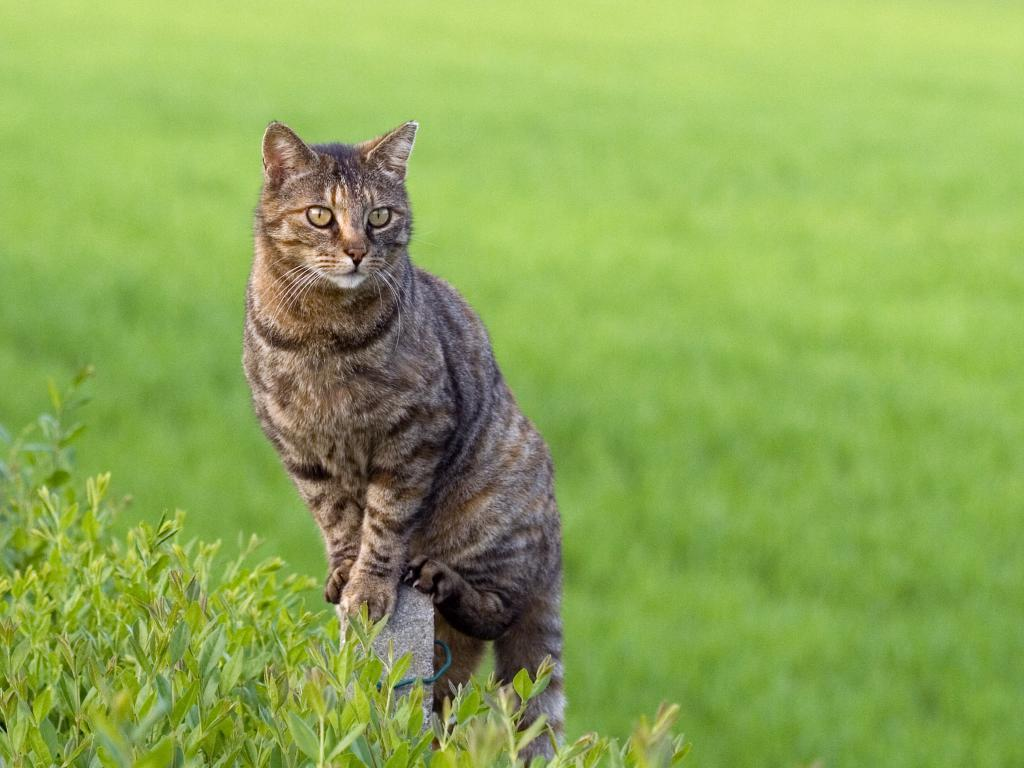What animal is present in the image? There is a cat in the image. Where is the cat positioned in the image? The cat is standing on a rock. What type of vegetation can be seen in the image? There are plants with leaves in the left bottom of the image. How would you describe the background of the image? The background of the image is blurry. What type of cave can be seen in the background of the image? There is no cave present in the image; the background is blurry. What color is the flag flying next to the cat in the image? There is no flag present in the image; it only features a cat standing on a rock and plants with leaves. 